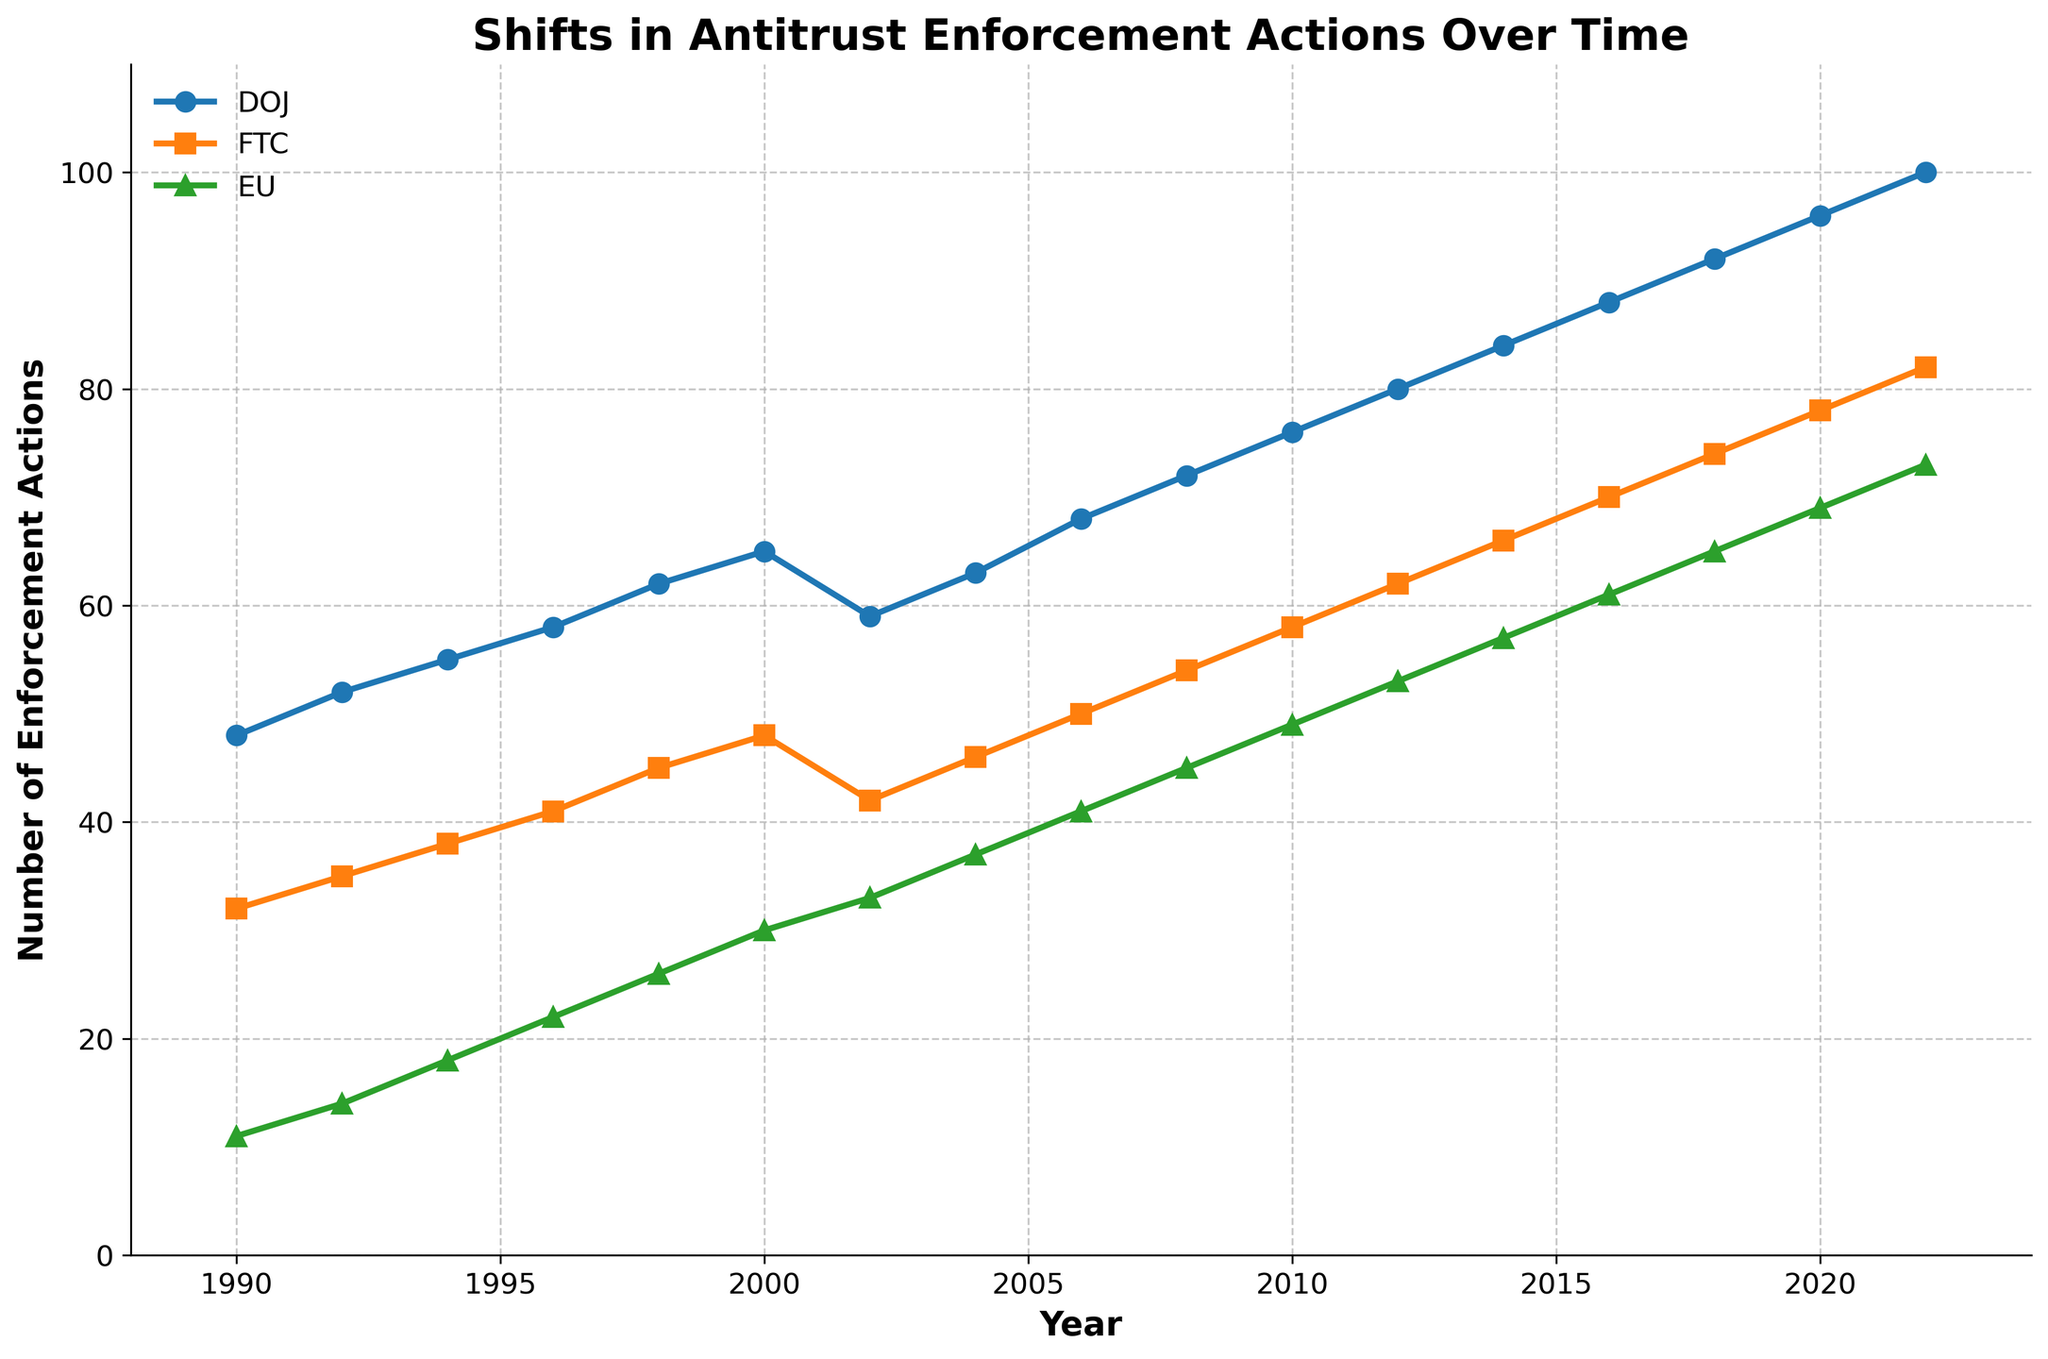Which agency had the highest number of enforcement actions in 2020? In 2020, the number of enforcement actions for DOJ was 96, for FTC was 78, and for EU was 69. Among these, the DOJ had the highest number of enforcement actions.
Answer: DOJ What is the difference between the DOJ and FTC enforcement actions in 2012? In 2012, the DOJ had 80 enforcement actions and the FTC had 62. The difference is calculated as 80 - 62 = 18.
Answer: 18 Between which years did the EU see the greatest increase in enforcement actions? The largest increase for the EU can be assessed by checking the increment differences between the consecutive years. The highest increase is 69 - 65 = 4 between 2018 and 2020.
Answer: 2018-2020 What were the enforcement action trends for the DOJ, FTC, and EU from 2000 to 2010? The DOJ actions increased from 65 to 76 (+11), the FTC increased from 48 to 58 (+10), and the EU increased from 30 to 49 (+19). Each agency shows a growing trend over this period.
Answer: All increasing How many total enforcement actions did the FTC have between 2000 and 2010? Summing the FTC enforcement actions from 2000 to 2010: 48 (2000) + 42 (2002) + 46 (2004) + 50 (2006) + 54 (2008) + 58 (2010) = 298.
Answer: 298 What is the average number of enforcement actions by the EU from 1990 to 2000? Summing the EU actions: 11 + 14 + 18 + 22 + 26 + 30 = 121. There are 6 data points, so the average is 121 / 6 ≈ 20.17.
Answer: 20.17 Which agency had the steepest increase in enforcement actions from 2010 to 2020? From 2010 to 2020, DOJ increased from 76 to 96 (+20), FTC from 58 to 78 (+20), and EU from 49 to 69 (+20). All agencies had the same steep increase of 20 actions.
Answer: All equal Compare the enforcement actions of DOJ and EU in 1994. Which one had more, and by how much? In 1994, DOJ had 55 and EU had 18. The DOJ had more by 55 - 18 = 37 enforcement actions.
Answer: DOJ by 37 